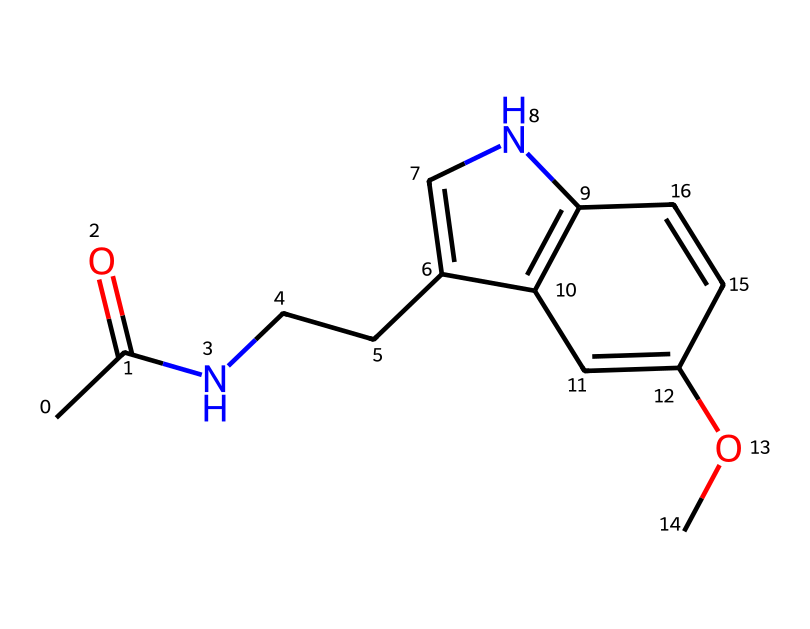What is the molecular formula of this chemical? To determine the molecular formula, we count the number of each type of atom present in the structure. From the SMILES representation, we can identify that there are 13 carbon atoms, 16 hydrogen atoms, 2 nitrogen atoms, and 2 oxygen atoms. Therefore, the molecular formula is C13H16N2O2.
Answer: C13H16N2O2 How many rings are present in the structure? By analyzing the structure, we look for the cyclic components, which are indicated by the numbers in the SMILES. There are two instances of "1" and "2," indicating that this compound contains two fused rings.
Answer: 2 What type of functional groups can be identified in this chemical? In the SMILES, we can see that there is an amide group (due to the presence of the carbonyl (C=O) bonded to a nitrogen (N)), as well as a methoxy group (C-O-CH3). These functional groups confer specific chemical properties.
Answer: amide and methoxy What is the significance of the nitrogen atoms in this structure? The nitrogen atoms are part of the amide and the heterocyclic aromatic ring system, which contribute to the neurotransmitter activity of melatonin. Nitrogen atoms often influence the biological activity and solubility of organic compounds.
Answer: biological activity How many double bonds are in the structure? To determine the number of double bonds, we look for instances of '=' in the SMILES representation. There are four '=' symbols in the structure, indicating that there are four double bonds present.
Answer: 4 What is the role of melatonin in the body? Melatonin is primarily known for regulating sleep-wake cycles by influencing circadian rhythms, helping to signal the body when it is time to sleep. This connection to sleep is crucial for many physiological processes.
Answer: sleep regulation 